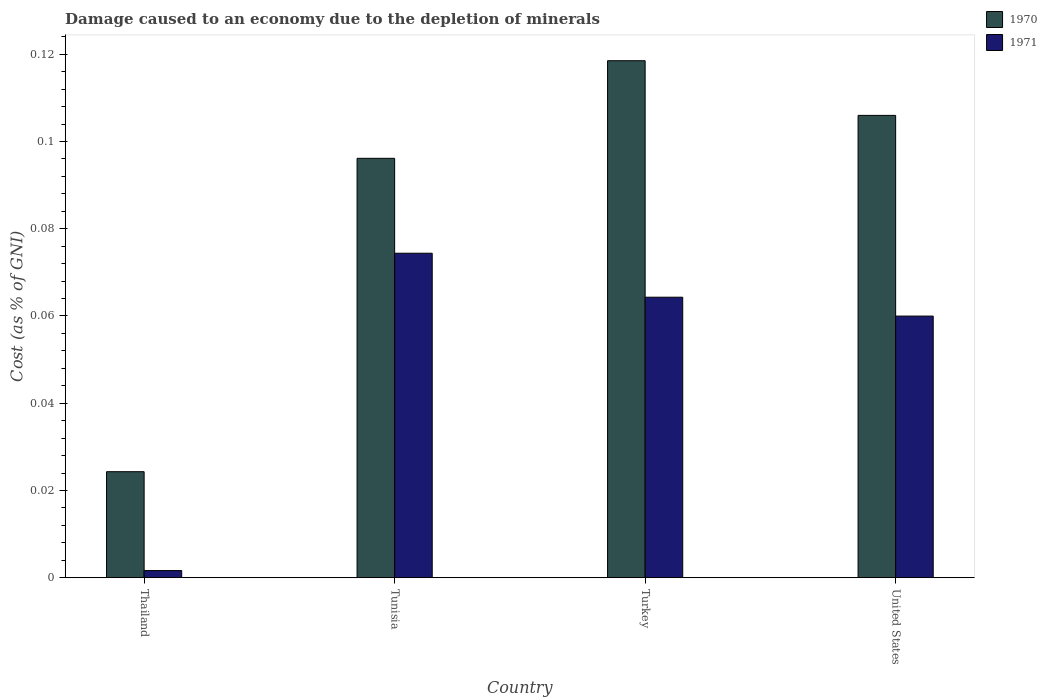How many different coloured bars are there?
Keep it short and to the point. 2. How many groups of bars are there?
Provide a short and direct response. 4. Are the number of bars per tick equal to the number of legend labels?
Make the answer very short. Yes. Are the number of bars on each tick of the X-axis equal?
Provide a succinct answer. Yes. How many bars are there on the 1st tick from the right?
Ensure brevity in your answer.  2. What is the label of the 1st group of bars from the left?
Give a very brief answer. Thailand. What is the cost of damage caused due to the depletion of minerals in 1970 in Thailand?
Make the answer very short. 0.02. Across all countries, what is the maximum cost of damage caused due to the depletion of minerals in 1971?
Your answer should be compact. 0.07. Across all countries, what is the minimum cost of damage caused due to the depletion of minerals in 1970?
Your answer should be compact. 0.02. In which country was the cost of damage caused due to the depletion of minerals in 1971 maximum?
Your answer should be very brief. Tunisia. In which country was the cost of damage caused due to the depletion of minerals in 1970 minimum?
Give a very brief answer. Thailand. What is the total cost of damage caused due to the depletion of minerals in 1970 in the graph?
Your answer should be very brief. 0.34. What is the difference between the cost of damage caused due to the depletion of minerals in 1971 in Thailand and that in Turkey?
Your answer should be very brief. -0.06. What is the difference between the cost of damage caused due to the depletion of minerals in 1971 in Thailand and the cost of damage caused due to the depletion of minerals in 1970 in Tunisia?
Provide a short and direct response. -0.09. What is the average cost of damage caused due to the depletion of minerals in 1970 per country?
Give a very brief answer. 0.09. What is the difference between the cost of damage caused due to the depletion of minerals of/in 1971 and cost of damage caused due to the depletion of minerals of/in 1970 in Turkey?
Make the answer very short. -0.05. What is the ratio of the cost of damage caused due to the depletion of minerals in 1971 in Thailand to that in United States?
Your answer should be very brief. 0.03. Is the cost of damage caused due to the depletion of minerals in 1971 in Tunisia less than that in United States?
Give a very brief answer. No. Is the difference between the cost of damage caused due to the depletion of minerals in 1971 in Turkey and United States greater than the difference between the cost of damage caused due to the depletion of minerals in 1970 in Turkey and United States?
Give a very brief answer. No. What is the difference between the highest and the second highest cost of damage caused due to the depletion of minerals in 1971?
Ensure brevity in your answer.  0.01. What is the difference between the highest and the lowest cost of damage caused due to the depletion of minerals in 1971?
Offer a terse response. 0.07. What does the 1st bar from the left in United States represents?
Your answer should be compact. 1970. What does the 2nd bar from the right in Turkey represents?
Your response must be concise. 1970. How many bars are there?
Keep it short and to the point. 8. What is the difference between two consecutive major ticks on the Y-axis?
Your answer should be compact. 0.02. Are the values on the major ticks of Y-axis written in scientific E-notation?
Your answer should be very brief. No. Where does the legend appear in the graph?
Ensure brevity in your answer.  Top right. How many legend labels are there?
Your answer should be very brief. 2. What is the title of the graph?
Keep it short and to the point. Damage caused to an economy due to the depletion of minerals. What is the label or title of the X-axis?
Make the answer very short. Country. What is the label or title of the Y-axis?
Offer a very short reply. Cost (as % of GNI). What is the Cost (as % of GNI) of 1970 in Thailand?
Offer a terse response. 0.02. What is the Cost (as % of GNI) of 1971 in Thailand?
Make the answer very short. 0. What is the Cost (as % of GNI) in 1970 in Tunisia?
Your response must be concise. 0.1. What is the Cost (as % of GNI) in 1971 in Tunisia?
Your answer should be compact. 0.07. What is the Cost (as % of GNI) in 1970 in Turkey?
Your answer should be very brief. 0.12. What is the Cost (as % of GNI) in 1971 in Turkey?
Offer a terse response. 0.06. What is the Cost (as % of GNI) of 1970 in United States?
Your answer should be compact. 0.11. What is the Cost (as % of GNI) of 1971 in United States?
Keep it short and to the point. 0.06. Across all countries, what is the maximum Cost (as % of GNI) of 1970?
Your answer should be compact. 0.12. Across all countries, what is the maximum Cost (as % of GNI) of 1971?
Make the answer very short. 0.07. Across all countries, what is the minimum Cost (as % of GNI) of 1970?
Provide a short and direct response. 0.02. Across all countries, what is the minimum Cost (as % of GNI) of 1971?
Your answer should be compact. 0. What is the total Cost (as % of GNI) in 1970 in the graph?
Ensure brevity in your answer.  0.34. What is the total Cost (as % of GNI) of 1971 in the graph?
Make the answer very short. 0.2. What is the difference between the Cost (as % of GNI) in 1970 in Thailand and that in Tunisia?
Provide a succinct answer. -0.07. What is the difference between the Cost (as % of GNI) in 1971 in Thailand and that in Tunisia?
Offer a terse response. -0.07. What is the difference between the Cost (as % of GNI) in 1970 in Thailand and that in Turkey?
Your answer should be compact. -0.09. What is the difference between the Cost (as % of GNI) in 1971 in Thailand and that in Turkey?
Keep it short and to the point. -0.06. What is the difference between the Cost (as % of GNI) of 1970 in Thailand and that in United States?
Your response must be concise. -0.08. What is the difference between the Cost (as % of GNI) in 1971 in Thailand and that in United States?
Keep it short and to the point. -0.06. What is the difference between the Cost (as % of GNI) of 1970 in Tunisia and that in Turkey?
Make the answer very short. -0.02. What is the difference between the Cost (as % of GNI) in 1971 in Tunisia and that in Turkey?
Your answer should be compact. 0.01. What is the difference between the Cost (as % of GNI) in 1970 in Tunisia and that in United States?
Keep it short and to the point. -0.01. What is the difference between the Cost (as % of GNI) of 1971 in Tunisia and that in United States?
Give a very brief answer. 0.01. What is the difference between the Cost (as % of GNI) of 1970 in Turkey and that in United States?
Keep it short and to the point. 0.01. What is the difference between the Cost (as % of GNI) of 1971 in Turkey and that in United States?
Your answer should be compact. 0. What is the difference between the Cost (as % of GNI) of 1970 in Thailand and the Cost (as % of GNI) of 1971 in Tunisia?
Your response must be concise. -0.05. What is the difference between the Cost (as % of GNI) in 1970 in Thailand and the Cost (as % of GNI) in 1971 in Turkey?
Ensure brevity in your answer.  -0.04. What is the difference between the Cost (as % of GNI) of 1970 in Thailand and the Cost (as % of GNI) of 1971 in United States?
Your answer should be compact. -0.04. What is the difference between the Cost (as % of GNI) in 1970 in Tunisia and the Cost (as % of GNI) in 1971 in Turkey?
Offer a terse response. 0.03. What is the difference between the Cost (as % of GNI) in 1970 in Tunisia and the Cost (as % of GNI) in 1971 in United States?
Your response must be concise. 0.04. What is the difference between the Cost (as % of GNI) of 1970 in Turkey and the Cost (as % of GNI) of 1971 in United States?
Ensure brevity in your answer.  0.06. What is the average Cost (as % of GNI) in 1970 per country?
Ensure brevity in your answer.  0.09. What is the average Cost (as % of GNI) of 1971 per country?
Offer a very short reply. 0.05. What is the difference between the Cost (as % of GNI) of 1970 and Cost (as % of GNI) of 1971 in Thailand?
Your response must be concise. 0.02. What is the difference between the Cost (as % of GNI) of 1970 and Cost (as % of GNI) of 1971 in Tunisia?
Your response must be concise. 0.02. What is the difference between the Cost (as % of GNI) of 1970 and Cost (as % of GNI) of 1971 in Turkey?
Your answer should be very brief. 0.05. What is the difference between the Cost (as % of GNI) of 1970 and Cost (as % of GNI) of 1971 in United States?
Give a very brief answer. 0.05. What is the ratio of the Cost (as % of GNI) of 1970 in Thailand to that in Tunisia?
Offer a very short reply. 0.25. What is the ratio of the Cost (as % of GNI) of 1971 in Thailand to that in Tunisia?
Your answer should be very brief. 0.02. What is the ratio of the Cost (as % of GNI) of 1970 in Thailand to that in Turkey?
Ensure brevity in your answer.  0.21. What is the ratio of the Cost (as % of GNI) of 1971 in Thailand to that in Turkey?
Provide a short and direct response. 0.03. What is the ratio of the Cost (as % of GNI) of 1970 in Thailand to that in United States?
Your answer should be very brief. 0.23. What is the ratio of the Cost (as % of GNI) of 1971 in Thailand to that in United States?
Provide a succinct answer. 0.03. What is the ratio of the Cost (as % of GNI) of 1970 in Tunisia to that in Turkey?
Give a very brief answer. 0.81. What is the ratio of the Cost (as % of GNI) of 1971 in Tunisia to that in Turkey?
Offer a very short reply. 1.16. What is the ratio of the Cost (as % of GNI) in 1970 in Tunisia to that in United States?
Your answer should be very brief. 0.91. What is the ratio of the Cost (as % of GNI) of 1971 in Tunisia to that in United States?
Make the answer very short. 1.24. What is the ratio of the Cost (as % of GNI) in 1970 in Turkey to that in United States?
Your response must be concise. 1.12. What is the ratio of the Cost (as % of GNI) in 1971 in Turkey to that in United States?
Ensure brevity in your answer.  1.07. What is the difference between the highest and the second highest Cost (as % of GNI) in 1970?
Provide a succinct answer. 0.01. What is the difference between the highest and the second highest Cost (as % of GNI) of 1971?
Your answer should be compact. 0.01. What is the difference between the highest and the lowest Cost (as % of GNI) in 1970?
Your answer should be very brief. 0.09. What is the difference between the highest and the lowest Cost (as % of GNI) in 1971?
Keep it short and to the point. 0.07. 